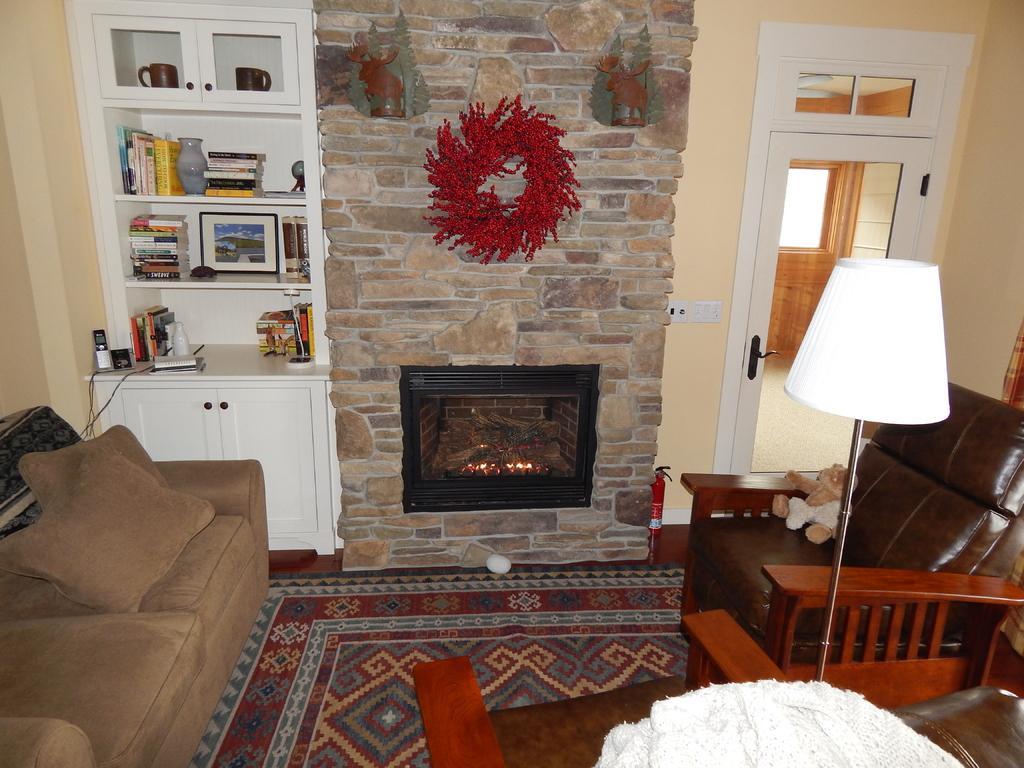Please provide a concise description of this image. This is inside of the room we can see sofa,chairs,wall,furniture,books,glass door,lamp with stand. From this glass door we can see wall,door,floor. We can see you on the chair. 